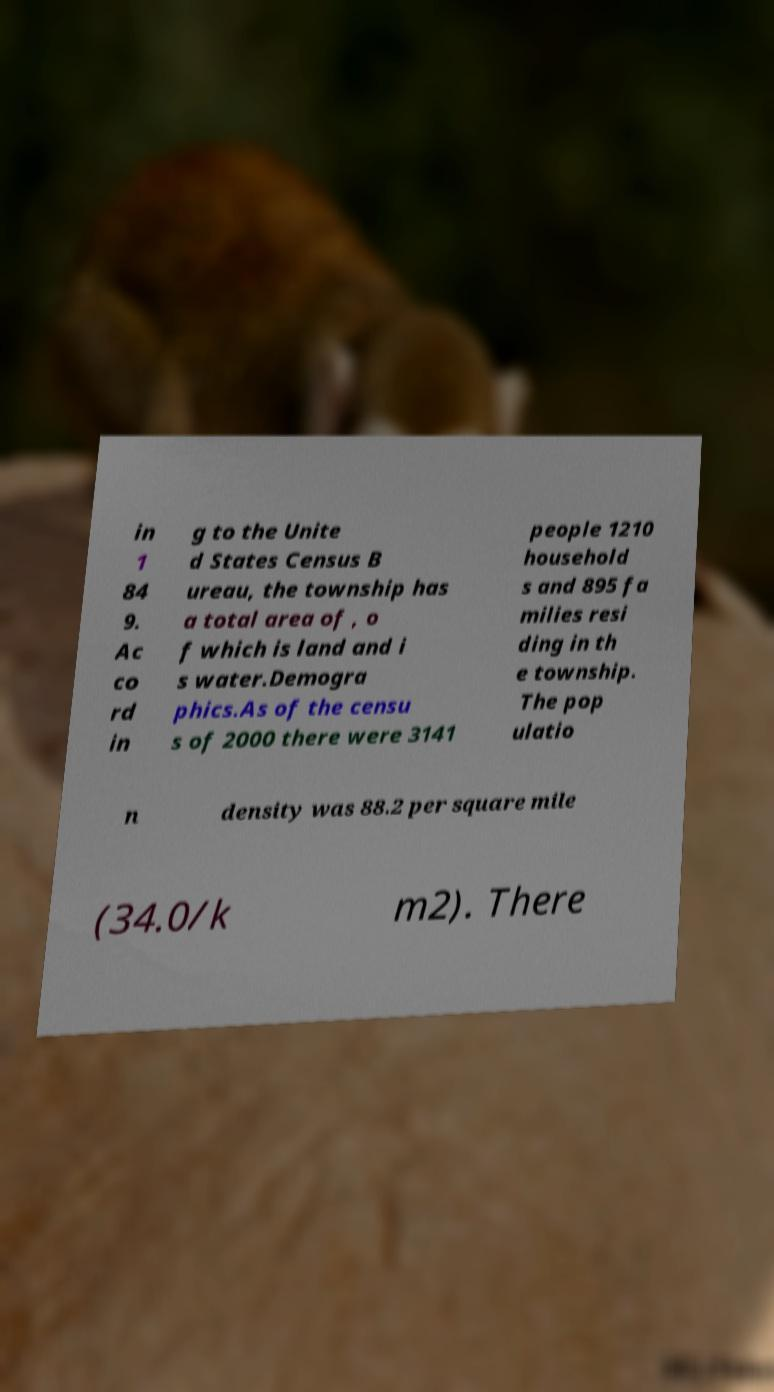Please read and relay the text visible in this image. What does it say? in 1 84 9. Ac co rd in g to the Unite d States Census B ureau, the township has a total area of , o f which is land and i s water.Demogra phics.As of the censu s of 2000 there were 3141 people 1210 household s and 895 fa milies resi ding in th e township. The pop ulatio n density was 88.2 per square mile (34.0/k m2). There 